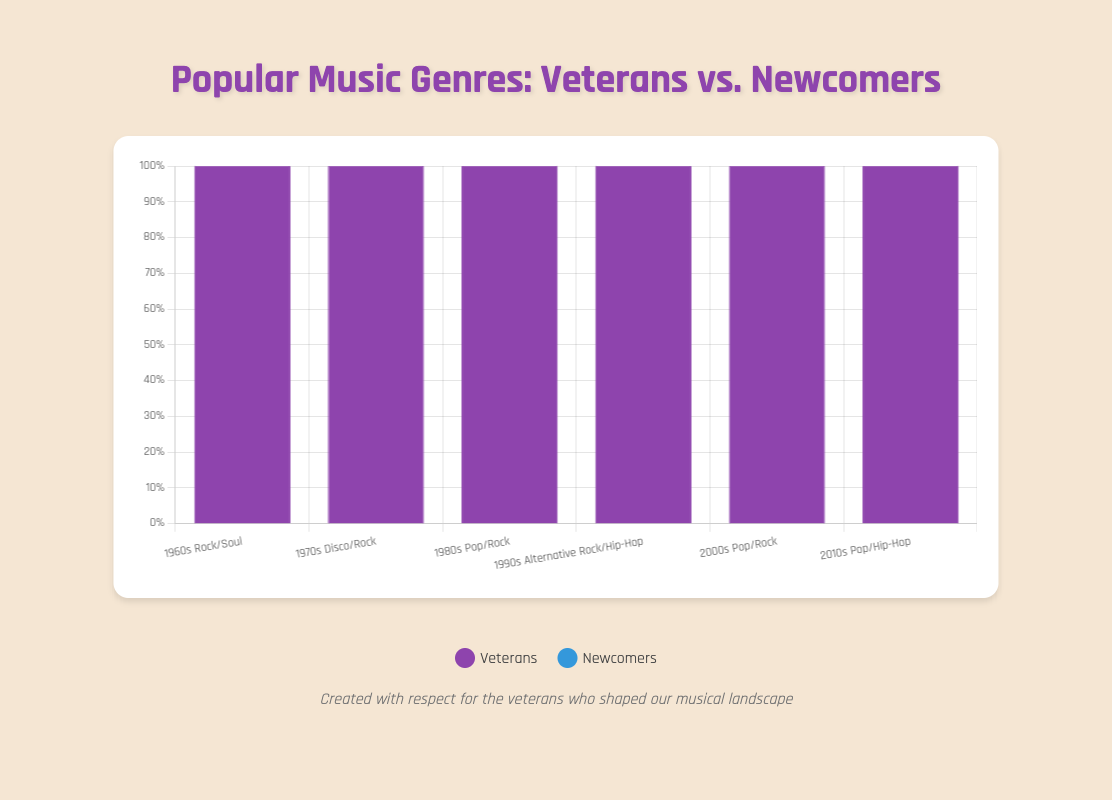How did the genre of Rock's representation by veterans change from the 1960s to the 2000s? To find this, we observe the veterans' contribution to Rock across these decades. In the 1960s, Rock veterans made up 70% (The Beatles 40% + The Rolling Stones 30%). In the 2000s, veterans like Linkin Park and Foo Fighters together contributed 70% (40% + 30%). Both decades have a 70% veteran contribution to Rock.
Answer: Remained the same Comparing the total representation of Pop veterans in the 1980s and 2010s, which decade has the greater percentage? In the 1980s, Pop veterans (Michael Jackson and Madonna) together made up 80% (50% + 30%). In the 2010s, Pop veterans (Lady Gaga and Taylor Swift) together made up 75% (40% + 35%). Therefore, the 1980s had a higher representation of Pop veterans.
Answer: 1980s What genre in the 1990s had the highest total percentage of newcomers? To find this, compare the percentage of newcomers in Alternative Rock and Hip-Hop in the 1990s. Alternative Rock newcomers (Radiohead and Green Day) made up 30% (20% + 10%). Hip-Hop newcomers (Eminem and Jay-Z) made up 35% (25% + 10%). Hip-Hop had the highest total percentage of newcomers.
Answer: Hip-Hop What is the visual trend of newcomer contributions across the decades from 1960s to 2010s? Observing the chart, we analyze the heights of newcomer bars across the decades. In the 1960s, the total newcomer contribution was 50% (Rock 30% + Soul 20%). In the 2010s, it was 25% (Pop 25% + Hip-Hop 25%). Generally, newcomer contributions showed a declining trend over the decades.
Answer: Declining What decade had the highest percentage of newcomer contribution in the Pop genre? We look at Pop contributions across the decades: In the 1980s, newcomers contributed 20% (Prince 15% + Whitney Houston 5%). In the 2000s, they contributed 35% (Beyoncé 25% + Rihanna 10%). In the 2010s, they contributed 25% (Billie Eilish 15% + Shawn Mendes 10%). The 2000s had the highest newcomer contribution in the Pop genre.
Answer: 2000s 